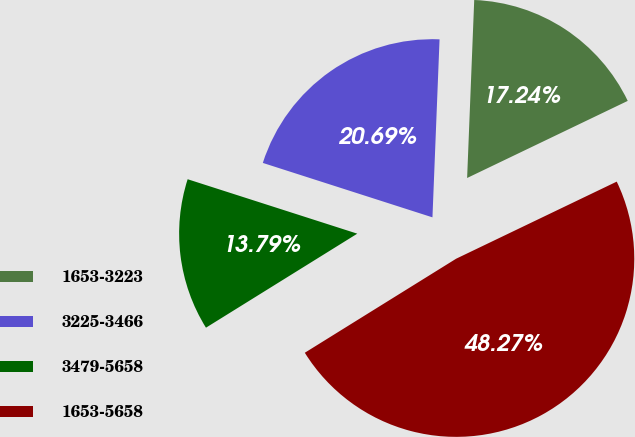<chart> <loc_0><loc_0><loc_500><loc_500><pie_chart><fcel>1653-3223<fcel>3225-3466<fcel>3479-5658<fcel>1653-5658<nl><fcel>17.24%<fcel>20.69%<fcel>13.79%<fcel>48.27%<nl></chart> 